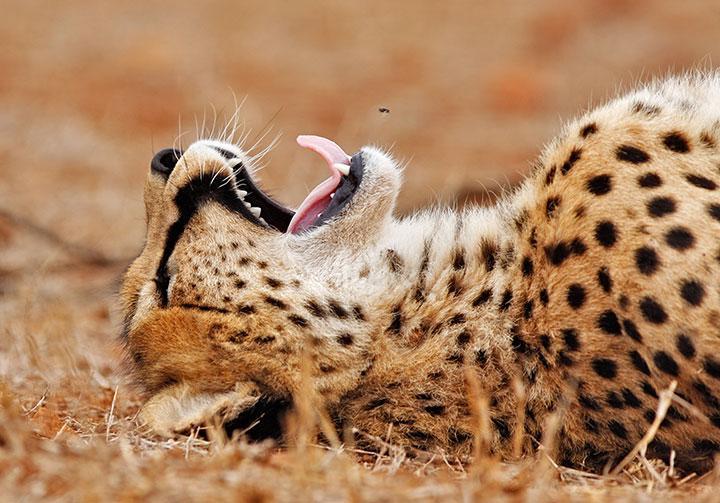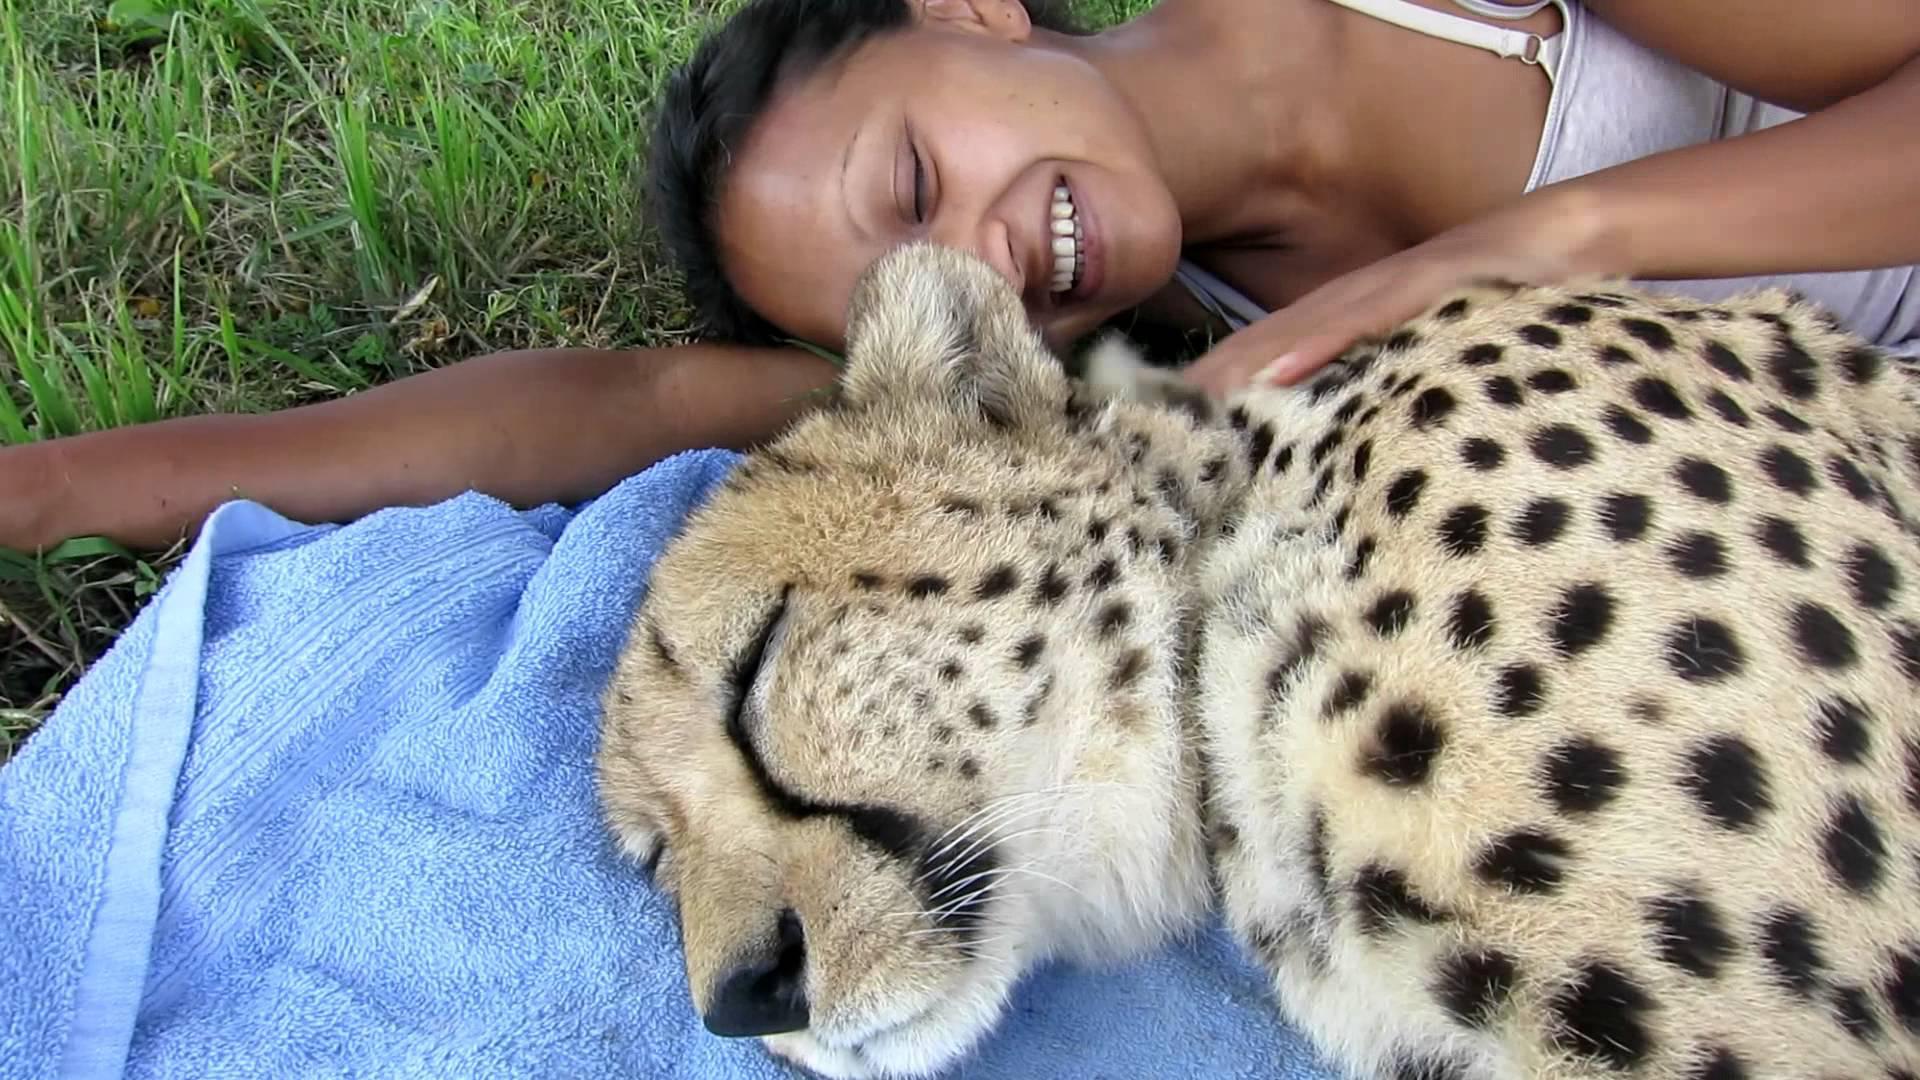The first image is the image on the left, the second image is the image on the right. For the images shown, is this caption "Each image shows a single cheetah." true? Answer yes or no. Yes. The first image is the image on the left, the second image is the image on the right. Given the left and right images, does the statement "There are at most 2 cheetahs in the image pair" hold true? Answer yes or no. Yes. 